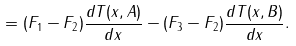Convert formula to latex. <formula><loc_0><loc_0><loc_500><loc_500>= ( F _ { 1 } - F _ { 2 } ) \frac { d T ( x , A ) } { d x } - ( F _ { 3 } - F _ { 2 } ) \frac { d T ( x , B ) } { d x } .</formula> 